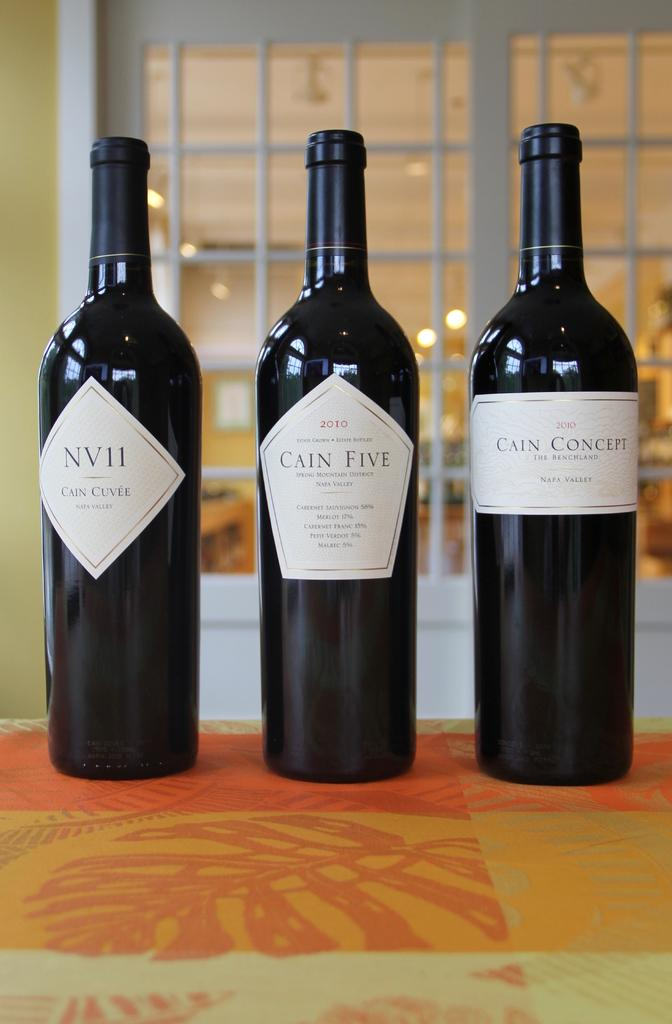<image>
Describe the image concisely. three bottles of wine next to each other, the center bottle is Cain Five. 